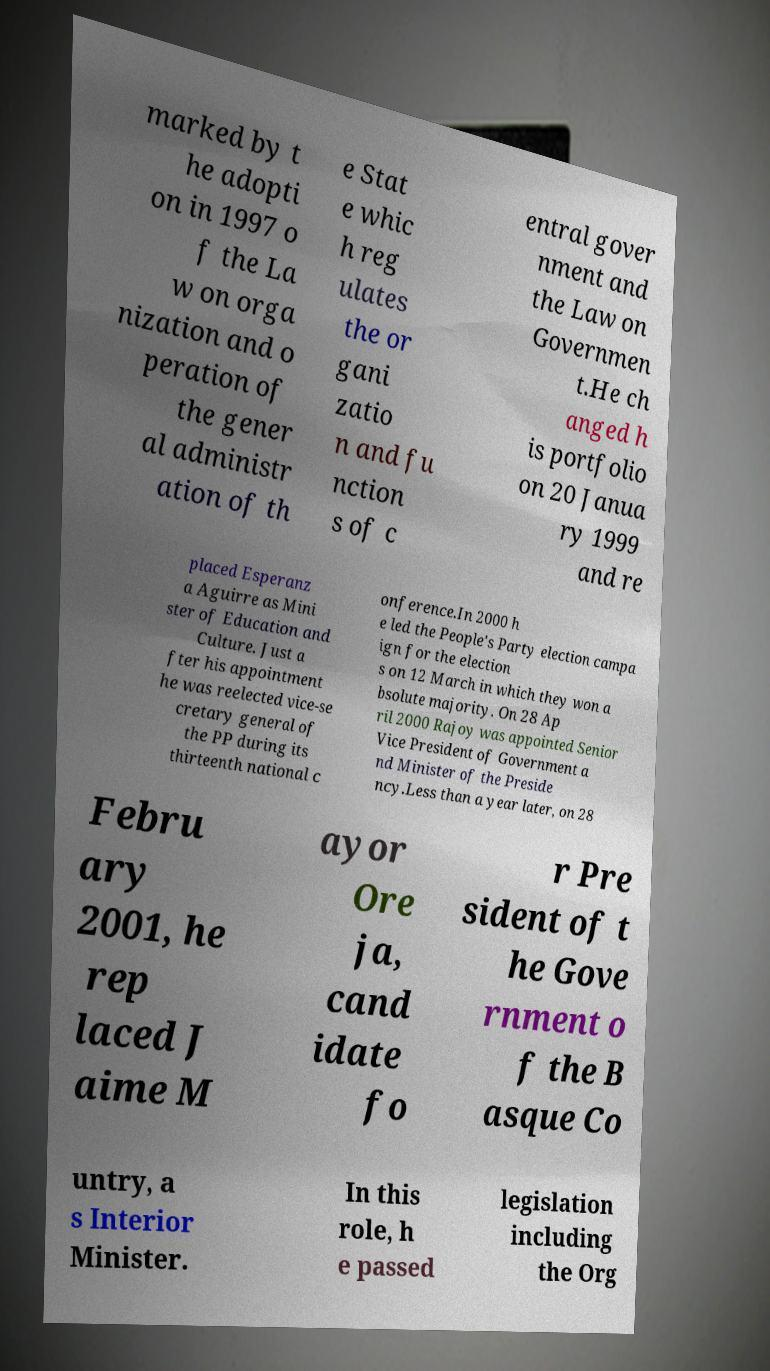There's text embedded in this image that I need extracted. Can you transcribe it verbatim? marked by t he adopti on in 1997 o f the La w on orga nization and o peration of the gener al administr ation of th e Stat e whic h reg ulates the or gani zatio n and fu nction s of c entral gover nment and the Law on Governmen t.He ch anged h is portfolio on 20 Janua ry 1999 and re placed Esperanz a Aguirre as Mini ster of Education and Culture. Just a fter his appointment he was reelected vice-se cretary general of the PP during its thirteenth national c onference.In 2000 h e led the People's Party election campa ign for the election s on 12 March in which they won a bsolute majority. On 28 Ap ril 2000 Rajoy was appointed Senior Vice President of Government a nd Minister of the Preside ncy.Less than a year later, on 28 Febru ary 2001, he rep laced J aime M ayor Ore ja, cand idate fo r Pre sident of t he Gove rnment o f the B asque Co untry, a s Interior Minister. In this role, h e passed legislation including the Org 